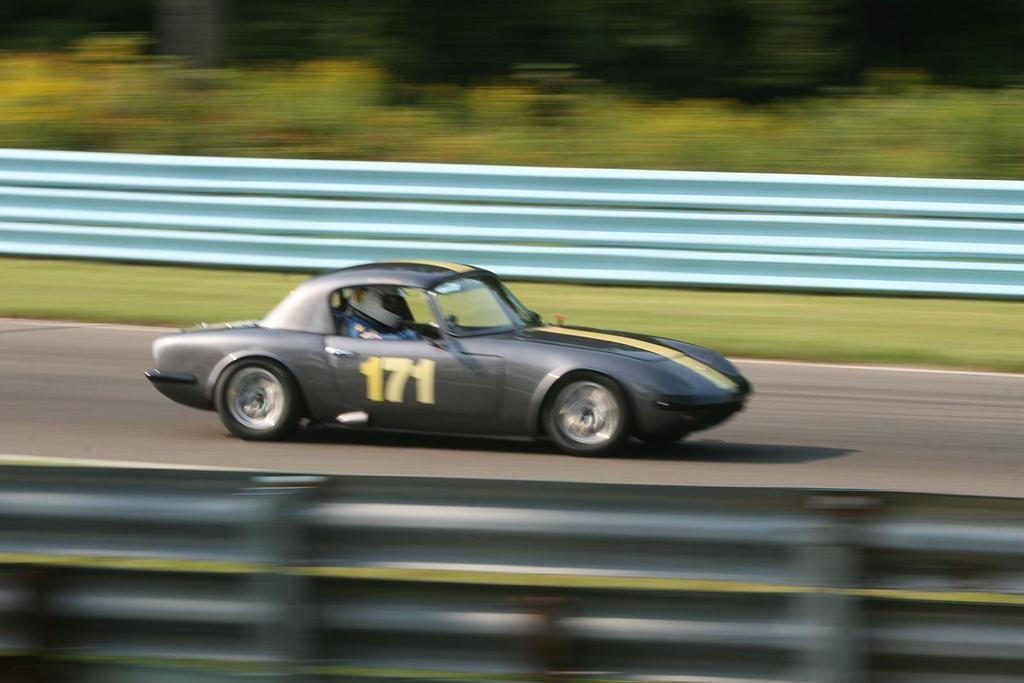What is the main subject of the image? There is a car on the road in the image. Can you describe the person inside the car? A person is sitting inside the car, and they are wearing a helmet. What is the purpose of the barricades on both sides of the road? The barricades on both sides of the road are likely there for safety or to control traffic. What can be seen in the background of the image? There are trees visible in the background of the image. What type of pipe is being used to create the ice sculpture in the image? There is no ice sculpture or pipe present in the image; it features a car on the road with a person wearing a helmet and barricades on both sides of the road. 